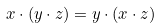Convert formula to latex. <formula><loc_0><loc_0><loc_500><loc_500>x \cdot ( y \cdot z ) = y \cdot ( x \cdot z )</formula> 